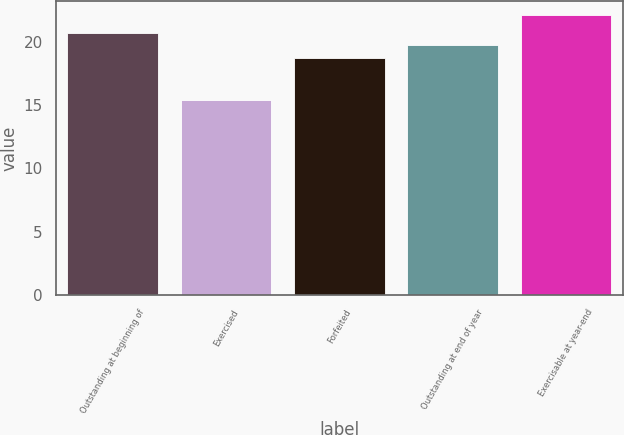Convert chart. <chart><loc_0><loc_0><loc_500><loc_500><bar_chart><fcel>Outstanding at beginning of<fcel>Exercised<fcel>Forfeited<fcel>Outstanding at end of year<fcel>Exercisable at year-end<nl><fcel>20.7<fcel>15.39<fcel>18.7<fcel>19.72<fcel>22.06<nl></chart> 